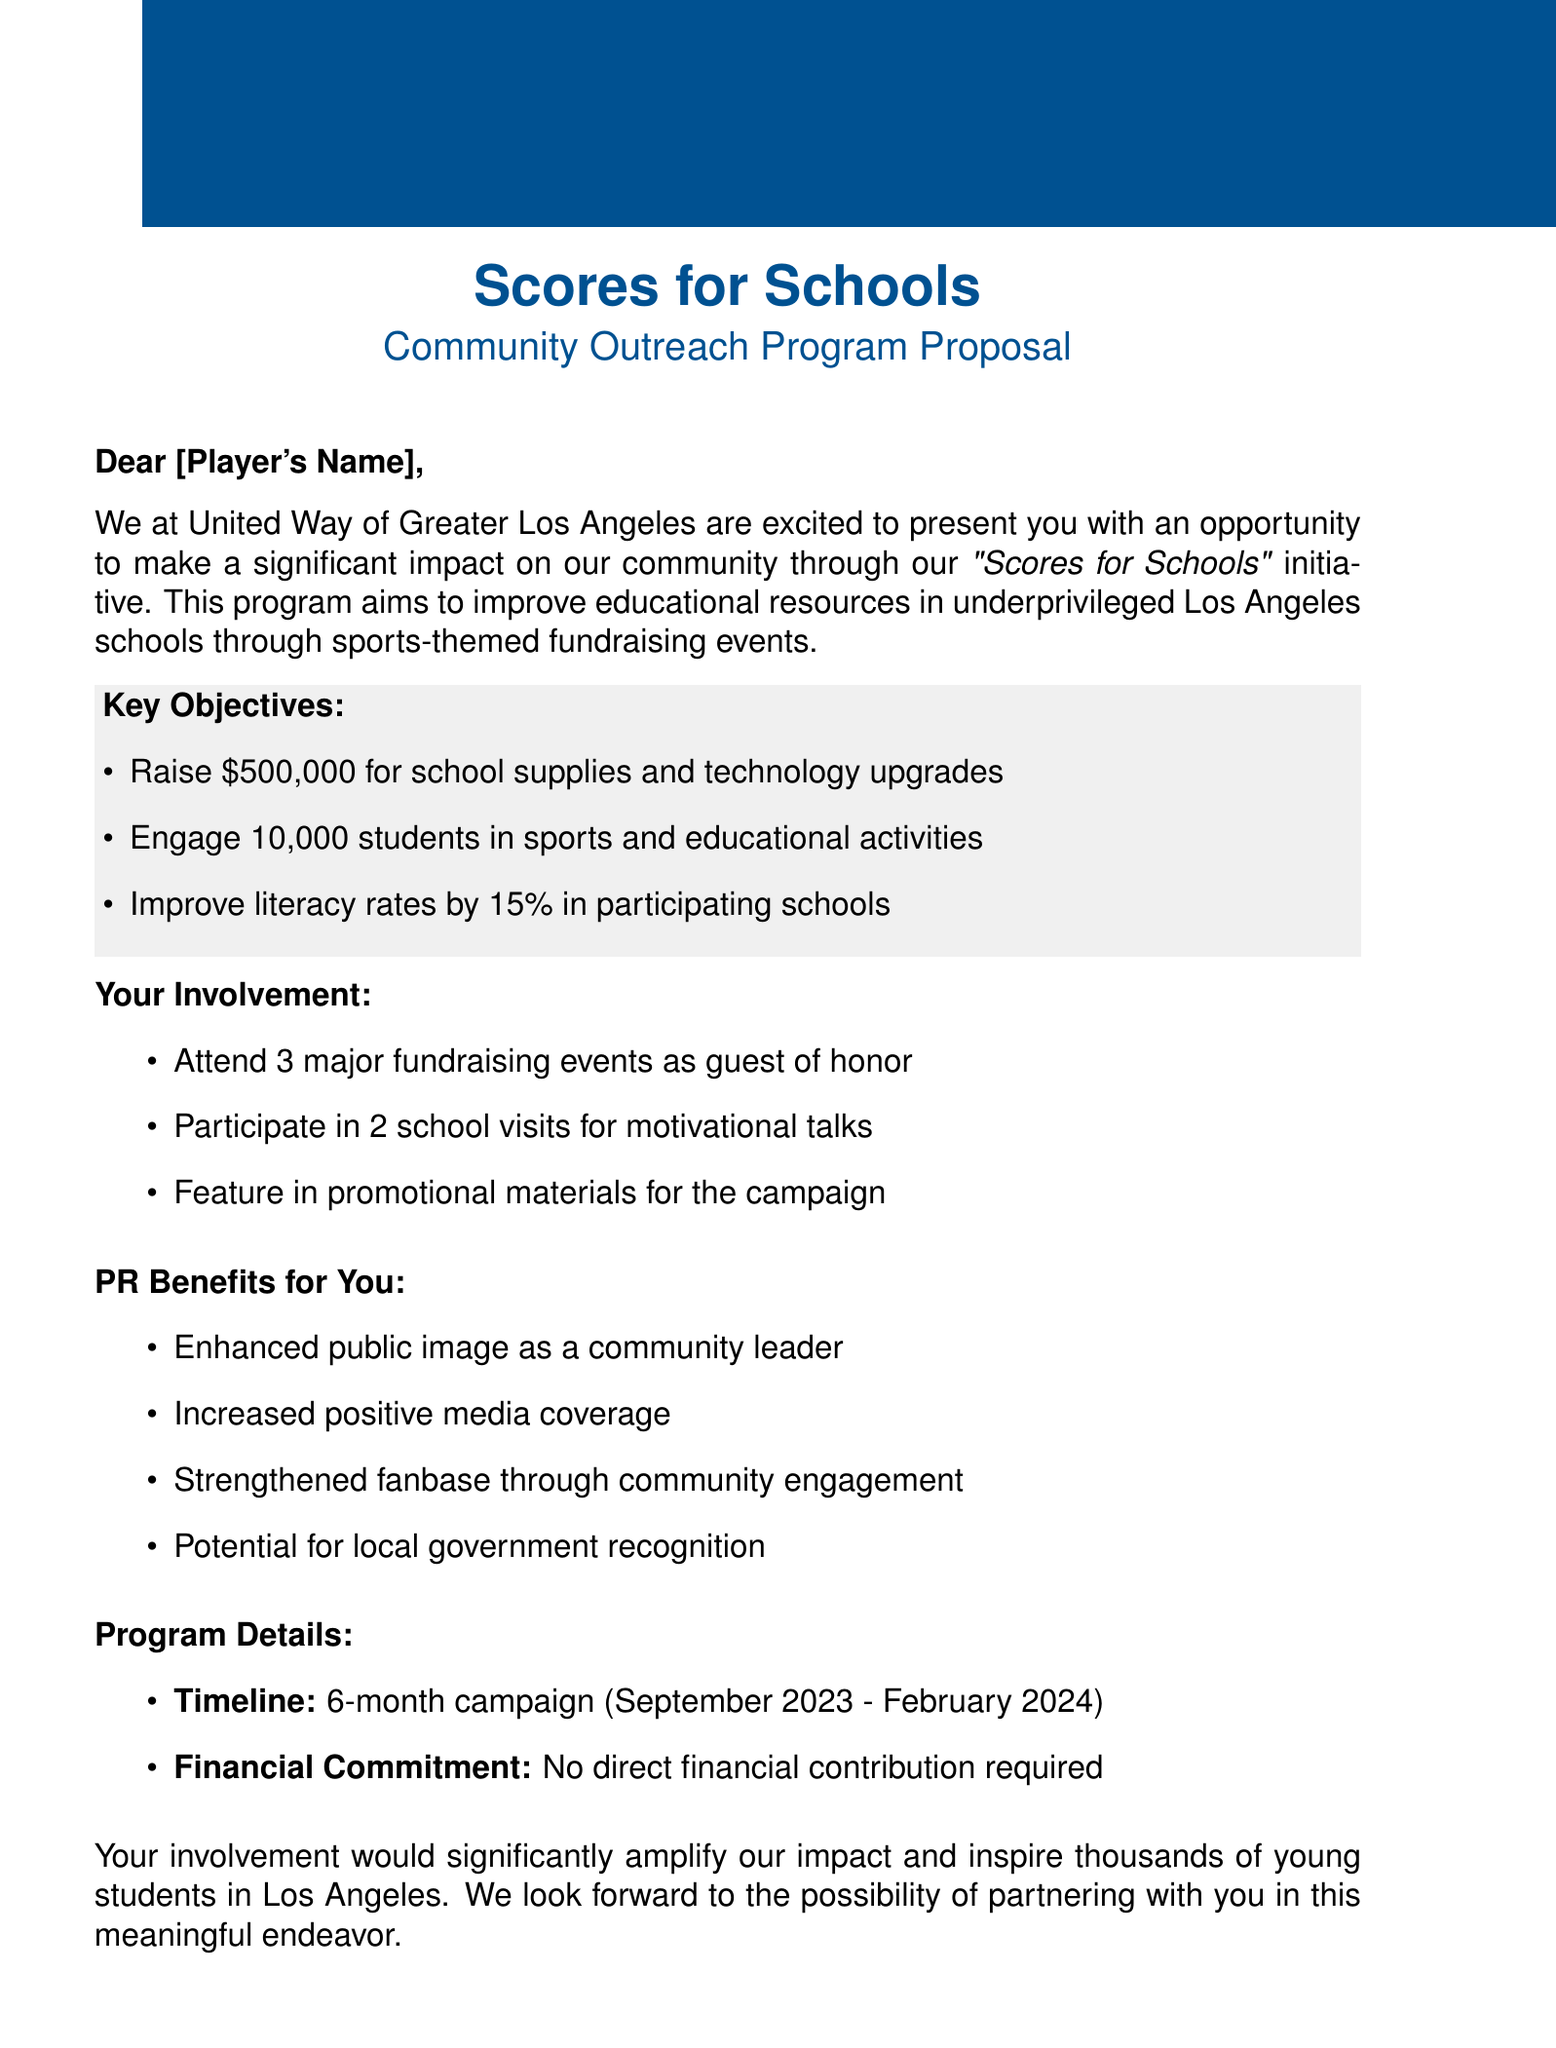What is the name of the program? The name of the program is mentioned in the introduction and is "Scores for Schools."
Answer: Scores for Schools Who is the sender of the proposal? The sender of the proposal is specified at the beginning of the document.
Answer: United Way of Greater Los Angeles How much money is aimed to be raised for school supplies? The amount aimed to be raised is listed under key objectives.
Answer: $500,000 What is the duration of the campaign? The duration of the campaign is detailed in the program details section.
Answer: 6-month campaign How many students are intended to be engaged in activities? The target number of engaged students is stated in the key objectives.
Answer: 10,000 students What is one PR benefit mentioned in the document? At least one PR benefit is highlighted under the PR benefits section.
Answer: Enhanced public image as a community leader Who is the contact person for this proposal? The contact person is listed at the end of the document.
Answer: Sarah Thompson How many fundraising events is the player expected to attend? The number of fundraising events the player is expected to attend is mentioned under player involvement.
Answer: 3 major fundraising events Is any financial contribution required from the player? The financial commitment section explicitly states if a financial contribution is needed.
Answer: No direct financial contribution required 